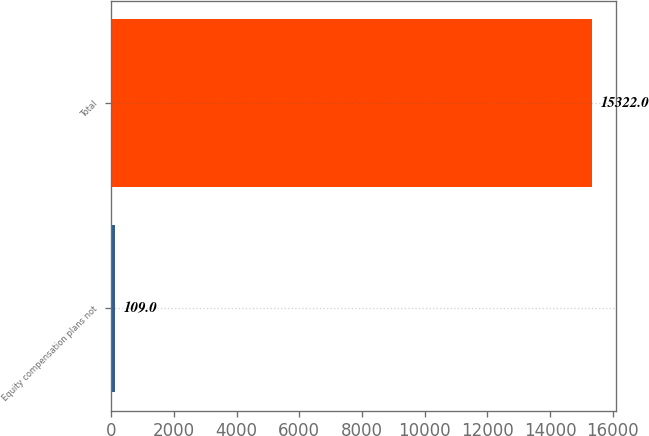Convert chart to OTSL. <chart><loc_0><loc_0><loc_500><loc_500><bar_chart><fcel>Equity compensation plans not<fcel>Total<nl><fcel>109<fcel>15322<nl></chart> 